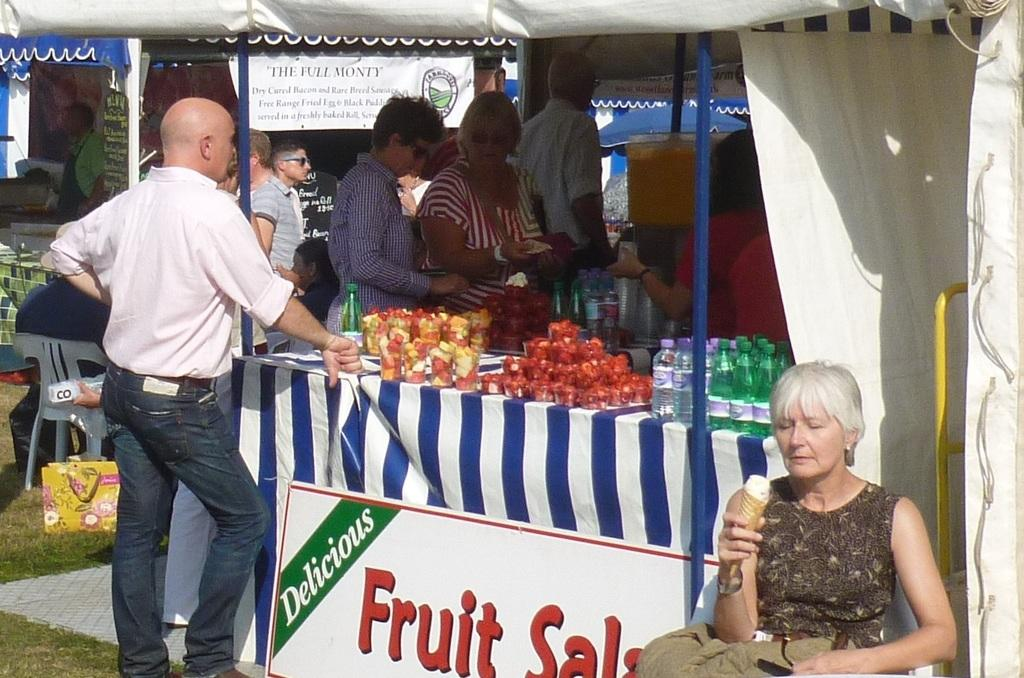How many people are in the image? There is a group of people in the image, but the exact number cannot be determined from the provided facts. What is the name board used for in the image? The name board is present in the image, but its purpose or function is not specified. What type of bottles can be seen in the image? There are bottles in the image, but their contents or purpose are not mentioned. What are the poles used for in the image? The purpose of the poles in the image is not specified. What is the tent used for in the image? The tent is present in the image, but its purpose or function is not mentioned. What type of fruits are in the image? There are fruits in the image, but their specific type is not mentioned. Can you describe the additional objects in the image? There are additional objects in the image, but their nature or purpose is not specified. What type of lead can be seen connecting the rods in the image? There is no mention of lead or rods in the image; the provided facts only mention a group of people, a name board, bottles, poles, a tent, fruits, and additional objects. What type of quince is being used as a decoration in the image? There is no mention of quince or decoration in the image; the provided facts only mention a group of people, a name board, bottles, poles, a tent, fruits, and additional objects. 